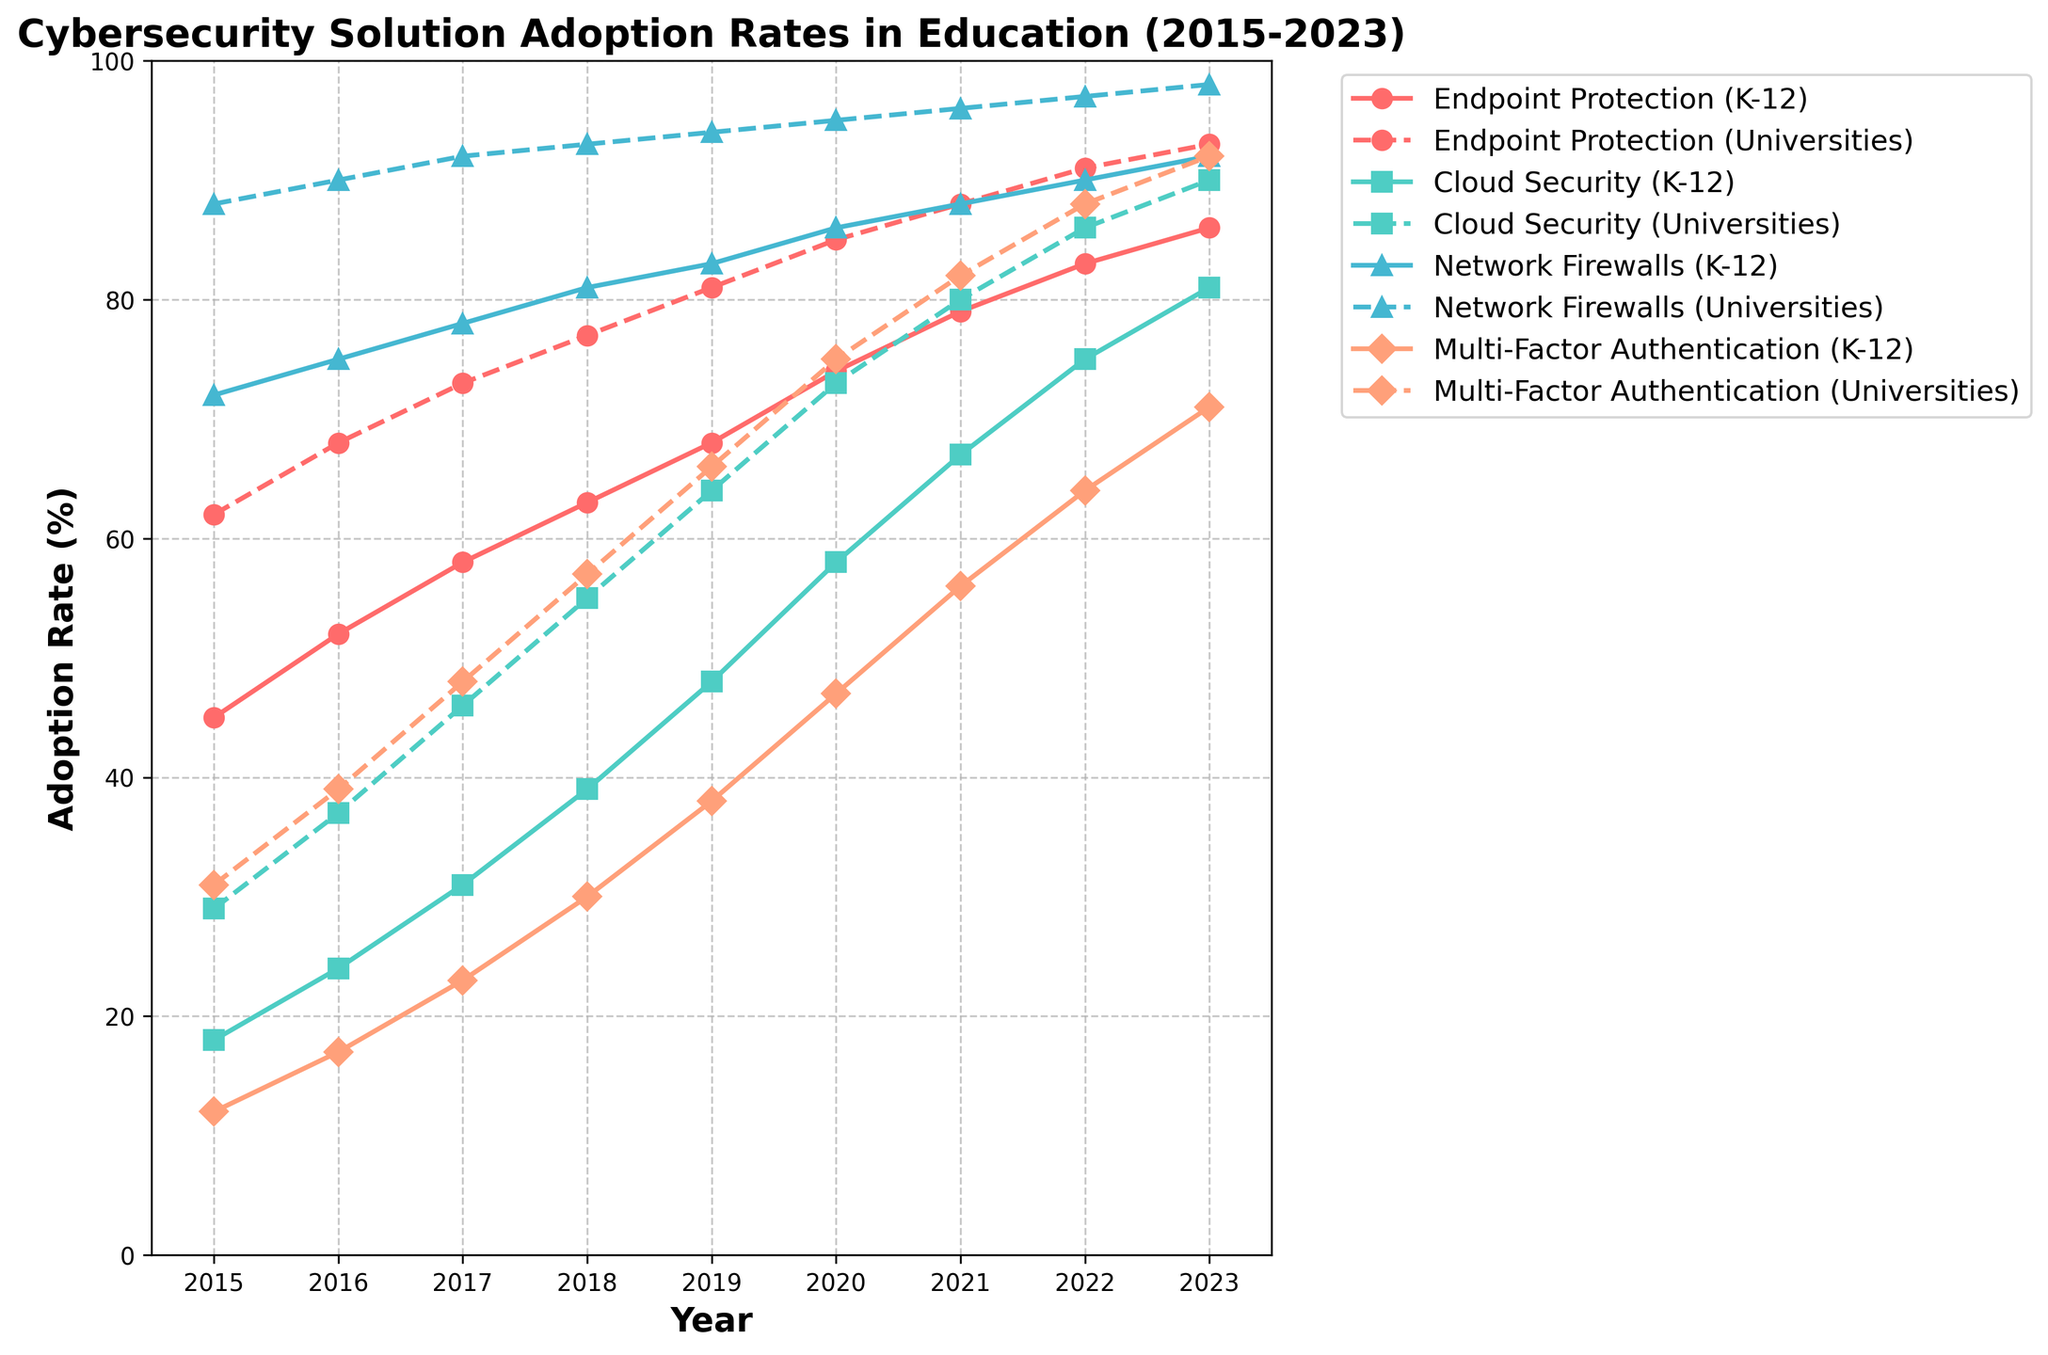How does the adoption rate of Endpoint Protection in K-12 schools compare to universities in 2023? In 2023, the adoption rate for Endpoint Protection in K-12 schools is approximately 86%, whereas for universities it is around 93%. By comparing these values directly, we see that the universities have a higher adoption rate.
Answer: Universities have a higher adoption rate Which cybersecurity solution shows the biggest difference in adoption rates between K-12 schools and universities in 2023? In 2023, we look at the adoption rates for each solution in both K-12 schools and universities: Endpoint Protection (86% vs 93%), Cloud Security (81% vs 90%), Network Firewalls (92% vs 98%), and Multi-Factor Authentication (71% vs 92%). The largest difference is observed in Multi-Factor Authentication with a difference of 21%.
Answer: Multi-Factor Authentication What is the overall trend in the adoption rate of Cloud Security in K-12 schools from 2015 to 2023? The adoption rate of Cloud Security in K-12 schools starts at 18% in 2015 and increases steadily each year, reaching 81% in 2023. This shows a consistent upward trend.
Answer: Increasing trend Between which consecutive years did universities see the largest increase in adoption rate of Multi-Factor Authentication? By examining the year-on-year increase for universities' Multi-Factor Authentication: 
2015-2016 (31% to 39% => 8%), 
2016-2017 (39% to 48% => 9%), 
2017-2018 (48% to 57% => 9%), 
2018-2019 (57% to 66% => 9%), 
2019-2020 (66% to 75% => 9%), 
2020-2021 (75% to 82% => 7%), 
2021-2022 (82% to 88% => 6%), 
2022-2023 (88% to 92% => 4%). 
The largest increase is 9% observed in 2016-2017, 2017-2018, 2018-2019, and 2019-2020.
Answer: 2016-2017, 2017-2018, 2018-2019, 2019-2020 In 2018, how much higher was the adoption rate of Network Firewalls in universities compared to K-12 schools? In 2018, the adoption rate of Network Firewalls in universities is 93%, and in K-12 schools, it is 81%. The difference between these rates is 93% - 81% = 12%.
Answer: 12% Which cybersecurity solution had the least difference in adoption rates between K-12 schools and universities in 2015? In 2015, the differences in adoption rates for each solution between K-12 schools and universities are: Endpoint Protection (62% - 45% = 17%), Cloud Security (29% - 18% = 11%), Network Firewalls (88% - 72% = 16%), Multi-Factor Authentication (31% - 12% = 19%). The smallest difference is observed in Cloud Security with a difference of 11%.
Answer: Cloud Security What is the average adoption rate of Endpoint Protection for K-12 schools over the given years? Adding the adoption rates from 2015 to 2023: (45 + 52 + 58 + 63 + 68 + 74 + 79 + 83 + 86) and then dividing by the number of years (9) gives an average of (608 / 9 ≈ 67.56).
Answer: 67.56% How does the adoption rate of Multi-Factor Authentication in K-12 schools in 2023 compare to that in 2018? In 2023, the adoption rate for Multi-Factor Authentication in K-12 schools is 71%, whereas in 2018 it is 30%. By comparing these values directly, we see a significant increase.
Answer: Higher in 2023 Which year witnessed the first instance of K-12 Cloud Security adoption rate surpassing 50%? Examining the Cloud Security adoption rates for K-12 schools, the values surpass 50% for the first time in 2020 with a rate of 58%.
Answer: 2020 